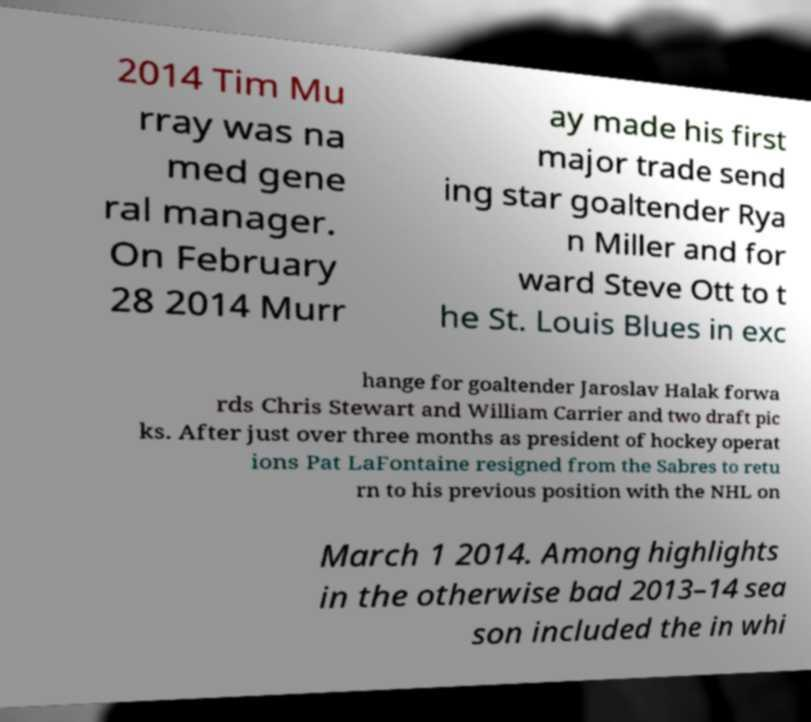What messages or text are displayed in this image? I need them in a readable, typed format. 2014 Tim Mu rray was na med gene ral manager. On February 28 2014 Murr ay made his first major trade send ing star goaltender Rya n Miller and for ward Steve Ott to t he St. Louis Blues in exc hange for goaltender Jaroslav Halak forwa rds Chris Stewart and William Carrier and two draft pic ks. After just over three months as president of hockey operat ions Pat LaFontaine resigned from the Sabres to retu rn to his previous position with the NHL on March 1 2014. Among highlights in the otherwise bad 2013–14 sea son included the in whi 